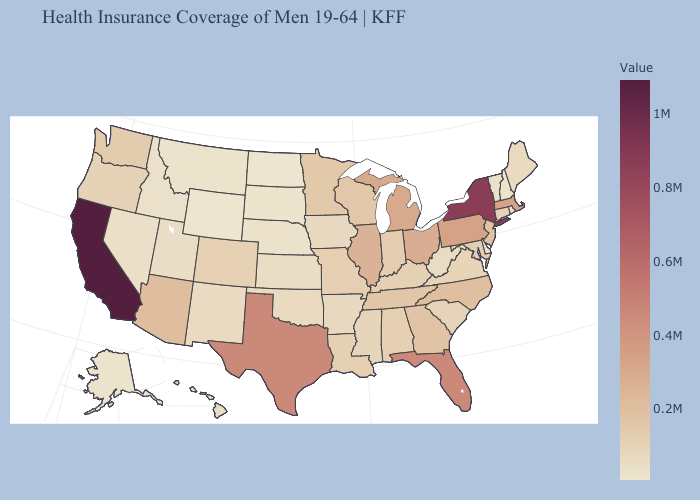Among the states that border Mississippi , does Tennessee have the highest value?
Give a very brief answer. Yes. Among the states that border Arkansas , which have the highest value?
Answer briefly. Texas. Does the map have missing data?
Write a very short answer. No. Among the states that border Alabama , does Mississippi have the lowest value?
Give a very brief answer. Yes. 